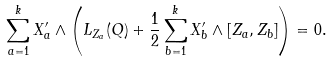Convert formula to latex. <formula><loc_0><loc_0><loc_500><loc_500>\sum _ { a = 1 } ^ { k } X ^ { \prime } _ { a } \wedge \left ( L _ { Z _ { a } } ( Q ) + \frac { 1 } { 2 } \sum _ { b = 1 } ^ { k } X ^ { \prime } _ { b } \wedge [ Z _ { a } , Z _ { b } ] \right ) = 0 .</formula> 